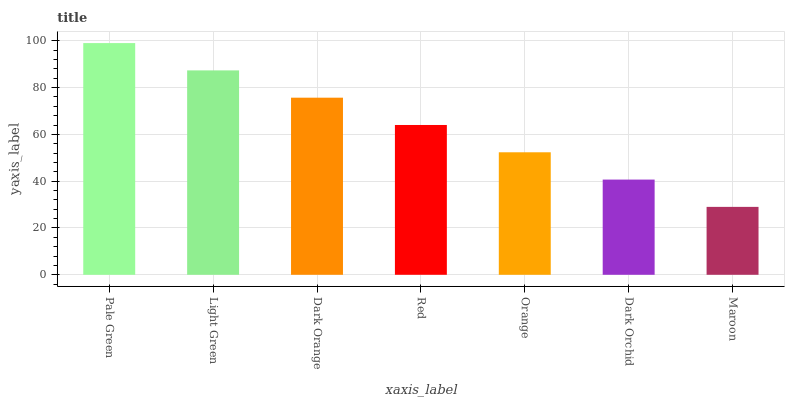Is Maroon the minimum?
Answer yes or no. Yes. Is Pale Green the maximum?
Answer yes or no. Yes. Is Light Green the minimum?
Answer yes or no. No. Is Light Green the maximum?
Answer yes or no. No. Is Pale Green greater than Light Green?
Answer yes or no. Yes. Is Light Green less than Pale Green?
Answer yes or no. Yes. Is Light Green greater than Pale Green?
Answer yes or no. No. Is Pale Green less than Light Green?
Answer yes or no. No. Is Red the high median?
Answer yes or no. Yes. Is Red the low median?
Answer yes or no. Yes. Is Dark Orchid the high median?
Answer yes or no. No. Is Orange the low median?
Answer yes or no. No. 